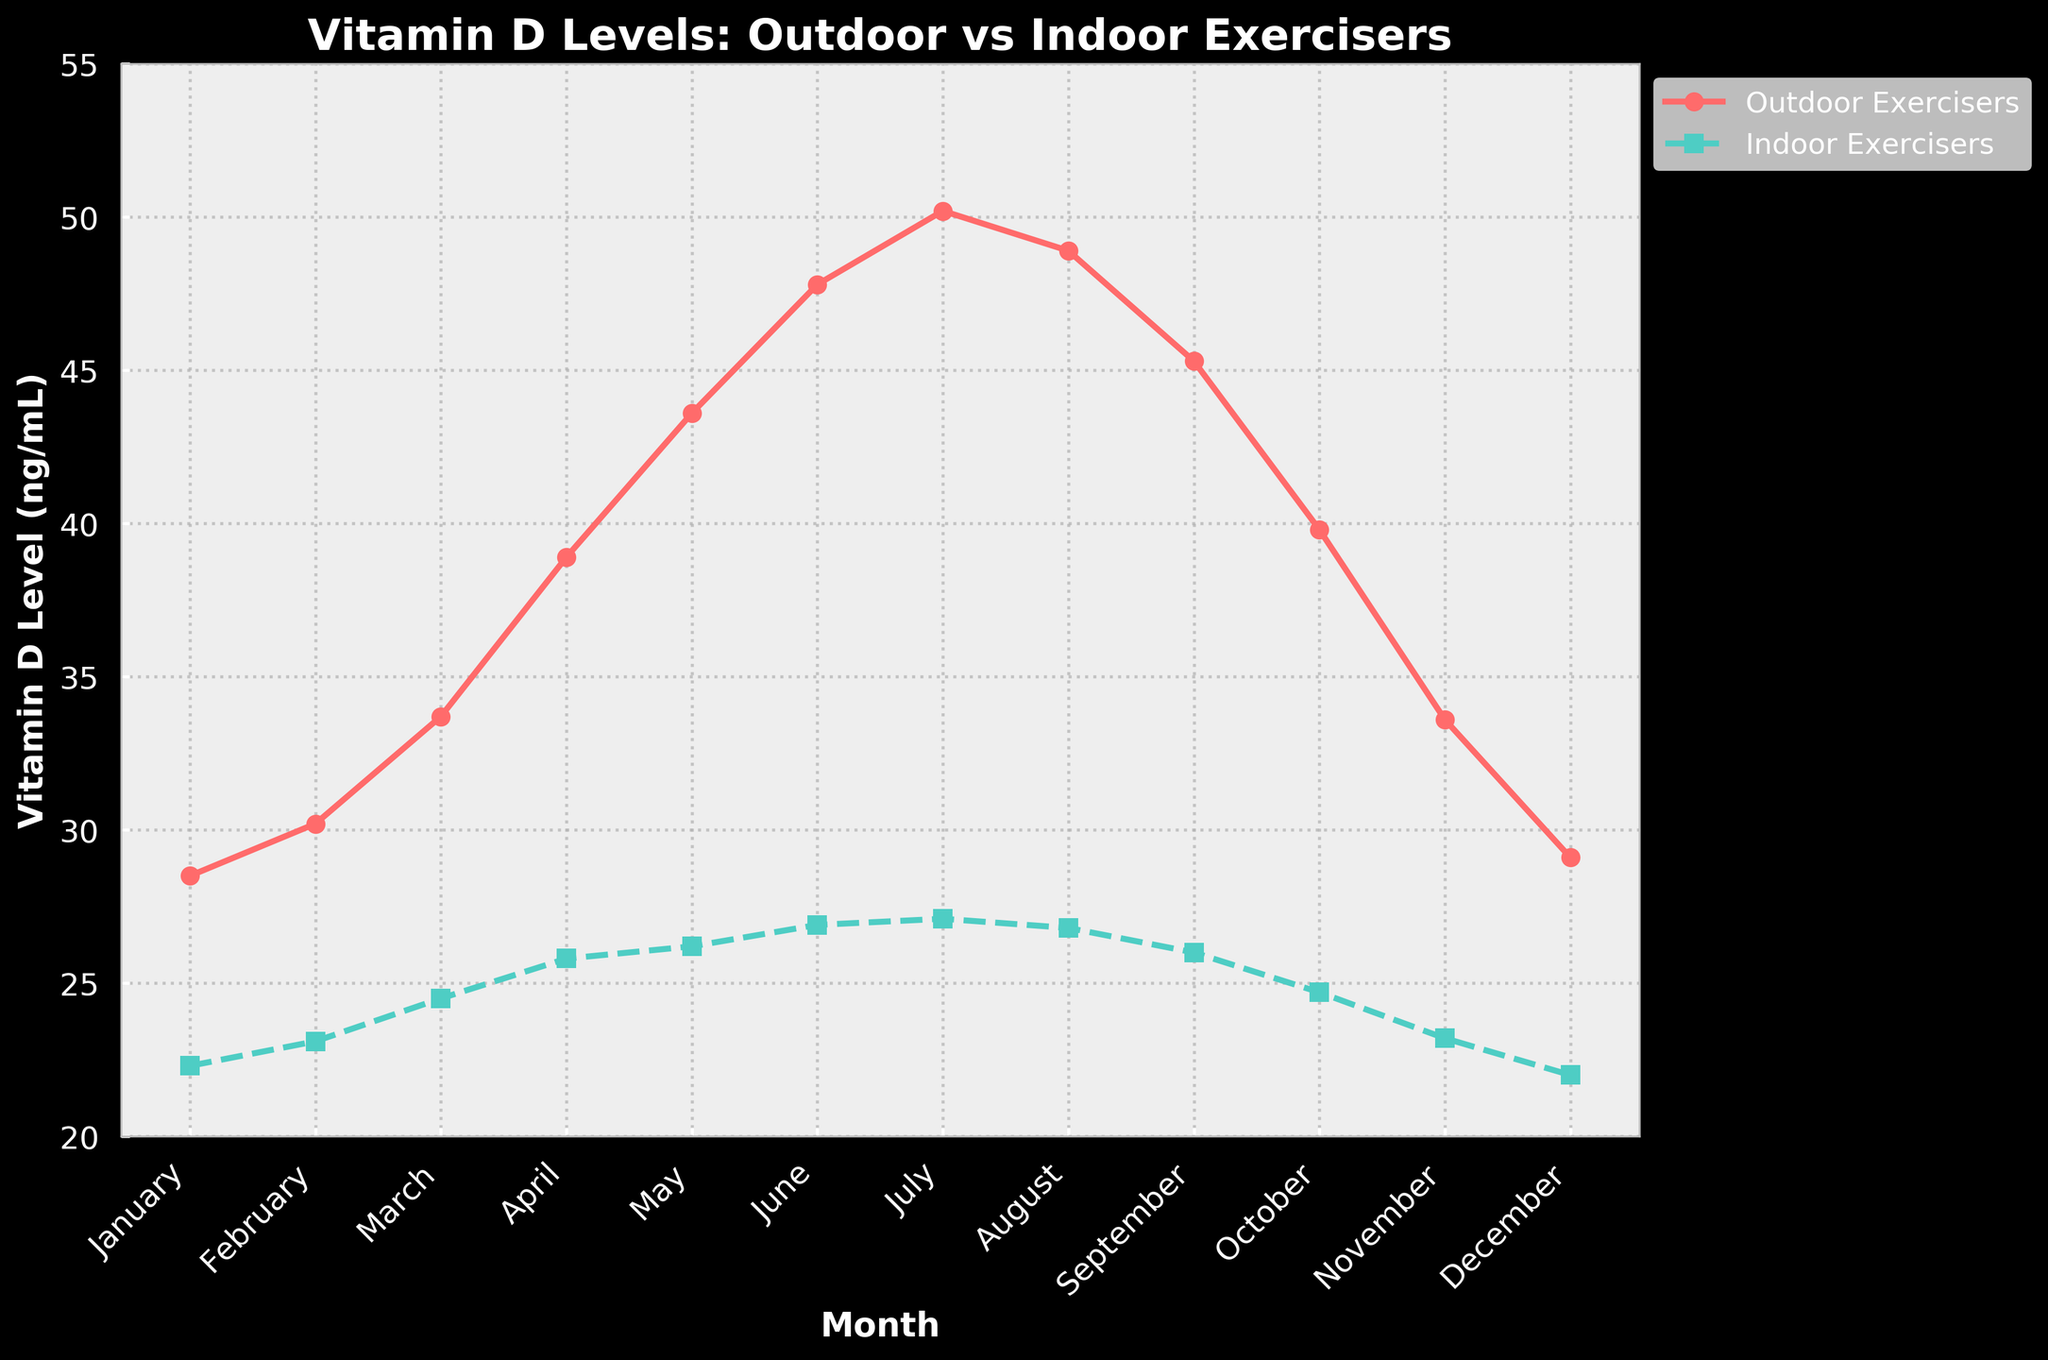Which month shows the highest vitamin D level for outdoor exercisers? The peak vitamin D level for outdoor exercisers is seen in July, as indicated by the highest point on the line for outdoor exercisers.
Answer: July What is the difference in vitamin D levels between outdoor and indoor exercisers in June? The vitamin D level for outdoor exercisers in June is 47.8 ng/mL and for indoor exercisers is 26.9 ng/mL. Subtracting the indoor level from the outdoor level: 47.8 - 26.9 = 20.9 ng/mL.
Answer: 20.9 ng/mL In which month is the gap between outdoor and indoor exercisers' vitamin D levels the smallest? The smallest gap can be observed in July by comparing the differences visually, or by calculating each month's difference and finding the smallest value. In July, the difference is 50.2 - 27.1 = 23.1 ng/mL.
Answer: July On average, do outdoor exercisers have higher vitamin D levels than indoor exercisers over the year? Yes, by visually comparing the two lines, the outdoor exercisers consistently have higher vitamin D levels throughout the year. Calculating the average for the entire year would confirm this.
Answer: Yes Which month has the lowest vitamin D level for indoor exercisers and what is the value? The lowest vitamin D level for indoor exercisers can be seen in December, as represented by the lowest point on the indoor exerciser's line, which is 22.0 ng/mL.
Answer: December, 22.0 ng/mL What is the overall trend in vitamin D levels for outdoor exercisers from January to December? Observing the line for outdoor exercisers, the trend shows a general increase from January to July, peaking in July, then gradually decreasing towards December.
Answer: Increase to July, then decrease How much higher is the peak vitamin D level for outdoor exercisers compared to the peak level for indoor exercisers? The peak for outdoor exercisers is in July at 50.2 ng/mL, and for indoor exercisers it is in July at 27.1 ng/mL. Subtracting the indoor peak from the outdoor peak: 50.2 - 27.1 = 23.1 ng/mL.
Answer: 23.1 ng/mL During which month is the vitamin D level for indoor exercisers closest to 25 ng/mL, and what is the actual value? By examining the indoor exercisers' line, the closest value to 25 ng/mL is in April, which is 25.8 ng/mL.
Answer: April, 25.8 ng/mL Is there any month where the vitamin D level of indoor exercisers is higher than 28 ng/mL? No, at no point does the vitamin D level of indoor exercisers exceed 28 ng/mL, as seen on the chart.
Answer: No What is the average vitamin D level for outdoor exercisers over the year? To get the average, sum the monthly levels for outdoor exercisers: (28.5 + 30.2 + 33.7 + 38.9 + 43.6 + 47.8 + 50.2 + 48.9 + 45.3 + 39.8 + 33.6 + 29.1) = 469.6 ng/mL. Divide by 12 (months): 469.6 / 12 ≈ 39.13 ng/mL.
Answer: 39.13 ng/mL 